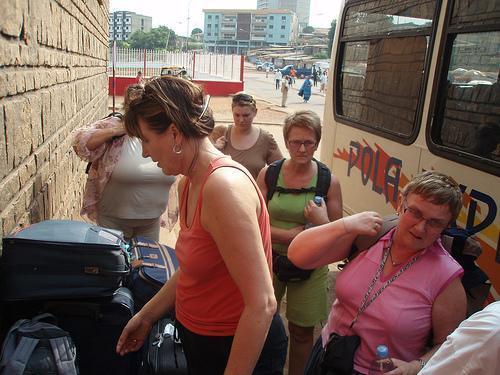How many people are shown beside the luggage?
Give a very brief answer. 6. How many bottles with blue lids are shown?
Give a very brief answer. 2. 